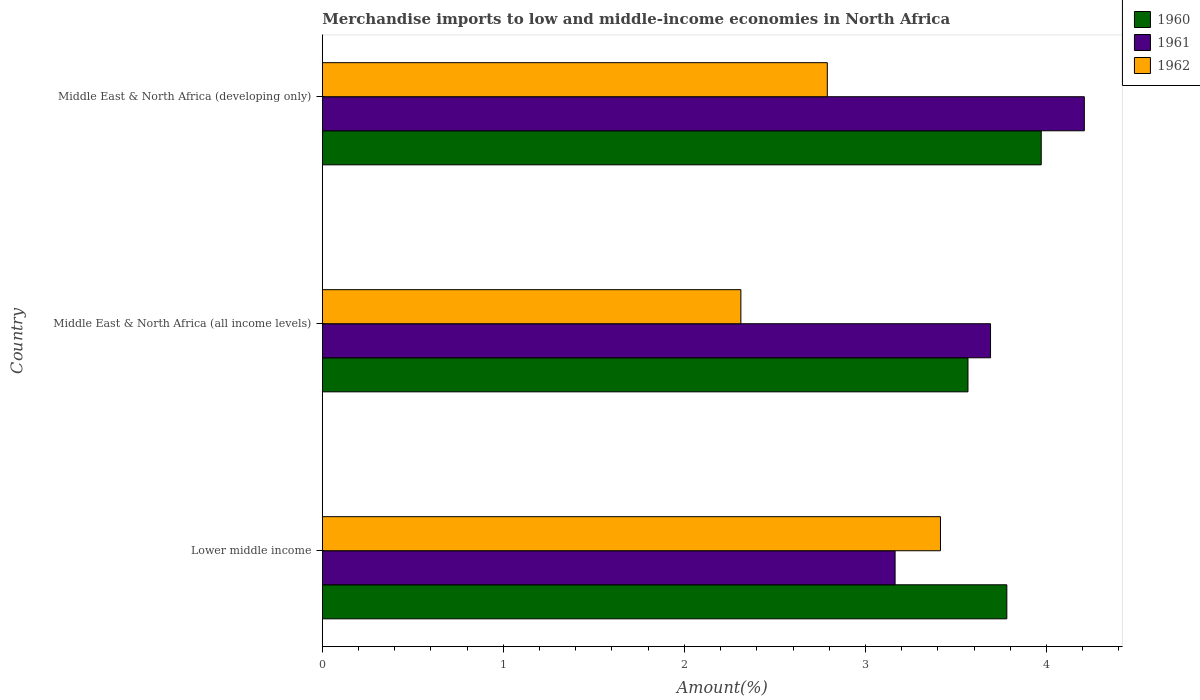How many different coloured bars are there?
Ensure brevity in your answer.  3. How many groups of bars are there?
Give a very brief answer. 3. How many bars are there on the 3rd tick from the top?
Make the answer very short. 3. What is the label of the 3rd group of bars from the top?
Give a very brief answer. Lower middle income. What is the percentage of amount earned from merchandise imports in 1960 in Middle East & North Africa (developing only)?
Offer a very short reply. 3.97. Across all countries, what is the maximum percentage of amount earned from merchandise imports in 1960?
Provide a short and direct response. 3.97. Across all countries, what is the minimum percentage of amount earned from merchandise imports in 1962?
Make the answer very short. 2.31. In which country was the percentage of amount earned from merchandise imports in 1960 maximum?
Ensure brevity in your answer.  Middle East & North Africa (developing only). In which country was the percentage of amount earned from merchandise imports in 1962 minimum?
Give a very brief answer. Middle East & North Africa (all income levels). What is the total percentage of amount earned from merchandise imports in 1962 in the graph?
Provide a succinct answer. 8.52. What is the difference between the percentage of amount earned from merchandise imports in 1961 in Lower middle income and that in Middle East & North Africa (all income levels)?
Provide a succinct answer. -0.53. What is the difference between the percentage of amount earned from merchandise imports in 1960 in Lower middle income and the percentage of amount earned from merchandise imports in 1962 in Middle East & North Africa (all income levels)?
Provide a short and direct response. 1.47. What is the average percentage of amount earned from merchandise imports in 1961 per country?
Your response must be concise. 3.69. What is the difference between the percentage of amount earned from merchandise imports in 1962 and percentage of amount earned from merchandise imports in 1961 in Middle East & North Africa (developing only)?
Make the answer very short. -1.42. What is the ratio of the percentage of amount earned from merchandise imports in 1961 in Middle East & North Africa (all income levels) to that in Middle East & North Africa (developing only)?
Make the answer very short. 0.88. What is the difference between the highest and the second highest percentage of amount earned from merchandise imports in 1961?
Your answer should be compact. 0.52. What is the difference between the highest and the lowest percentage of amount earned from merchandise imports in 1962?
Keep it short and to the point. 1.1. Is the sum of the percentage of amount earned from merchandise imports in 1960 in Lower middle income and Middle East & North Africa (all income levels) greater than the maximum percentage of amount earned from merchandise imports in 1962 across all countries?
Make the answer very short. Yes. Are the values on the major ticks of X-axis written in scientific E-notation?
Your answer should be very brief. No. Does the graph contain any zero values?
Offer a terse response. No. Does the graph contain grids?
Make the answer very short. No. How many legend labels are there?
Keep it short and to the point. 3. What is the title of the graph?
Your answer should be compact. Merchandise imports to low and middle-income economies in North Africa. What is the label or title of the X-axis?
Ensure brevity in your answer.  Amount(%). What is the label or title of the Y-axis?
Your response must be concise. Country. What is the Amount(%) of 1960 in Lower middle income?
Ensure brevity in your answer.  3.78. What is the Amount(%) in 1961 in Lower middle income?
Offer a terse response. 3.16. What is the Amount(%) of 1962 in Lower middle income?
Provide a succinct answer. 3.41. What is the Amount(%) in 1960 in Middle East & North Africa (all income levels)?
Keep it short and to the point. 3.57. What is the Amount(%) of 1961 in Middle East & North Africa (all income levels)?
Provide a succinct answer. 3.69. What is the Amount(%) of 1962 in Middle East & North Africa (all income levels)?
Provide a succinct answer. 2.31. What is the Amount(%) in 1960 in Middle East & North Africa (developing only)?
Offer a very short reply. 3.97. What is the Amount(%) of 1961 in Middle East & North Africa (developing only)?
Your answer should be compact. 4.21. What is the Amount(%) in 1962 in Middle East & North Africa (developing only)?
Ensure brevity in your answer.  2.79. Across all countries, what is the maximum Amount(%) of 1960?
Give a very brief answer. 3.97. Across all countries, what is the maximum Amount(%) in 1961?
Your response must be concise. 4.21. Across all countries, what is the maximum Amount(%) of 1962?
Give a very brief answer. 3.41. Across all countries, what is the minimum Amount(%) in 1960?
Keep it short and to the point. 3.57. Across all countries, what is the minimum Amount(%) in 1961?
Make the answer very short. 3.16. Across all countries, what is the minimum Amount(%) of 1962?
Offer a very short reply. 2.31. What is the total Amount(%) in 1960 in the graph?
Your response must be concise. 11.32. What is the total Amount(%) in 1961 in the graph?
Keep it short and to the point. 11.06. What is the total Amount(%) of 1962 in the graph?
Your answer should be very brief. 8.52. What is the difference between the Amount(%) of 1960 in Lower middle income and that in Middle East & North Africa (all income levels)?
Your response must be concise. 0.21. What is the difference between the Amount(%) of 1961 in Lower middle income and that in Middle East & North Africa (all income levels)?
Your answer should be compact. -0.53. What is the difference between the Amount(%) of 1962 in Lower middle income and that in Middle East & North Africa (all income levels)?
Give a very brief answer. 1.1. What is the difference between the Amount(%) in 1960 in Lower middle income and that in Middle East & North Africa (developing only)?
Offer a very short reply. -0.19. What is the difference between the Amount(%) of 1961 in Lower middle income and that in Middle East & North Africa (developing only)?
Keep it short and to the point. -1.05. What is the difference between the Amount(%) in 1962 in Lower middle income and that in Middle East & North Africa (developing only)?
Offer a very short reply. 0.63. What is the difference between the Amount(%) of 1960 in Middle East & North Africa (all income levels) and that in Middle East & North Africa (developing only)?
Ensure brevity in your answer.  -0.4. What is the difference between the Amount(%) of 1961 in Middle East & North Africa (all income levels) and that in Middle East & North Africa (developing only)?
Provide a succinct answer. -0.52. What is the difference between the Amount(%) of 1962 in Middle East & North Africa (all income levels) and that in Middle East & North Africa (developing only)?
Your answer should be compact. -0.48. What is the difference between the Amount(%) in 1960 in Lower middle income and the Amount(%) in 1961 in Middle East & North Africa (all income levels)?
Provide a short and direct response. 0.09. What is the difference between the Amount(%) of 1960 in Lower middle income and the Amount(%) of 1962 in Middle East & North Africa (all income levels)?
Offer a very short reply. 1.47. What is the difference between the Amount(%) in 1961 in Lower middle income and the Amount(%) in 1962 in Middle East & North Africa (all income levels)?
Offer a very short reply. 0.85. What is the difference between the Amount(%) in 1960 in Lower middle income and the Amount(%) in 1961 in Middle East & North Africa (developing only)?
Give a very brief answer. -0.43. What is the difference between the Amount(%) of 1960 in Lower middle income and the Amount(%) of 1962 in Middle East & North Africa (developing only)?
Your response must be concise. 0.99. What is the difference between the Amount(%) of 1961 in Lower middle income and the Amount(%) of 1962 in Middle East & North Africa (developing only)?
Offer a very short reply. 0.37. What is the difference between the Amount(%) of 1960 in Middle East & North Africa (all income levels) and the Amount(%) of 1961 in Middle East & North Africa (developing only)?
Make the answer very short. -0.64. What is the difference between the Amount(%) of 1960 in Middle East & North Africa (all income levels) and the Amount(%) of 1962 in Middle East & North Africa (developing only)?
Give a very brief answer. 0.78. What is the difference between the Amount(%) of 1961 in Middle East & North Africa (all income levels) and the Amount(%) of 1962 in Middle East & North Africa (developing only)?
Offer a terse response. 0.9. What is the average Amount(%) in 1960 per country?
Your answer should be very brief. 3.77. What is the average Amount(%) in 1961 per country?
Give a very brief answer. 3.69. What is the average Amount(%) in 1962 per country?
Ensure brevity in your answer.  2.84. What is the difference between the Amount(%) in 1960 and Amount(%) in 1961 in Lower middle income?
Provide a short and direct response. 0.62. What is the difference between the Amount(%) in 1960 and Amount(%) in 1962 in Lower middle income?
Your answer should be very brief. 0.37. What is the difference between the Amount(%) of 1961 and Amount(%) of 1962 in Lower middle income?
Offer a terse response. -0.25. What is the difference between the Amount(%) in 1960 and Amount(%) in 1961 in Middle East & North Africa (all income levels)?
Offer a very short reply. -0.12. What is the difference between the Amount(%) of 1960 and Amount(%) of 1962 in Middle East & North Africa (all income levels)?
Your answer should be very brief. 1.25. What is the difference between the Amount(%) of 1961 and Amount(%) of 1962 in Middle East & North Africa (all income levels)?
Give a very brief answer. 1.38. What is the difference between the Amount(%) in 1960 and Amount(%) in 1961 in Middle East & North Africa (developing only)?
Make the answer very short. -0.24. What is the difference between the Amount(%) of 1960 and Amount(%) of 1962 in Middle East & North Africa (developing only)?
Your answer should be compact. 1.18. What is the difference between the Amount(%) in 1961 and Amount(%) in 1962 in Middle East & North Africa (developing only)?
Ensure brevity in your answer.  1.42. What is the ratio of the Amount(%) in 1960 in Lower middle income to that in Middle East & North Africa (all income levels)?
Offer a terse response. 1.06. What is the ratio of the Amount(%) in 1961 in Lower middle income to that in Middle East & North Africa (all income levels)?
Make the answer very short. 0.86. What is the ratio of the Amount(%) of 1962 in Lower middle income to that in Middle East & North Africa (all income levels)?
Provide a succinct answer. 1.48. What is the ratio of the Amount(%) in 1960 in Lower middle income to that in Middle East & North Africa (developing only)?
Give a very brief answer. 0.95. What is the ratio of the Amount(%) of 1961 in Lower middle income to that in Middle East & North Africa (developing only)?
Ensure brevity in your answer.  0.75. What is the ratio of the Amount(%) of 1962 in Lower middle income to that in Middle East & North Africa (developing only)?
Make the answer very short. 1.22. What is the ratio of the Amount(%) in 1960 in Middle East & North Africa (all income levels) to that in Middle East & North Africa (developing only)?
Your response must be concise. 0.9. What is the ratio of the Amount(%) in 1961 in Middle East & North Africa (all income levels) to that in Middle East & North Africa (developing only)?
Give a very brief answer. 0.88. What is the ratio of the Amount(%) of 1962 in Middle East & North Africa (all income levels) to that in Middle East & North Africa (developing only)?
Provide a short and direct response. 0.83. What is the difference between the highest and the second highest Amount(%) of 1960?
Your answer should be very brief. 0.19. What is the difference between the highest and the second highest Amount(%) of 1961?
Offer a very short reply. 0.52. What is the difference between the highest and the second highest Amount(%) in 1962?
Provide a succinct answer. 0.63. What is the difference between the highest and the lowest Amount(%) in 1960?
Give a very brief answer. 0.4. What is the difference between the highest and the lowest Amount(%) of 1961?
Keep it short and to the point. 1.05. What is the difference between the highest and the lowest Amount(%) of 1962?
Give a very brief answer. 1.1. 